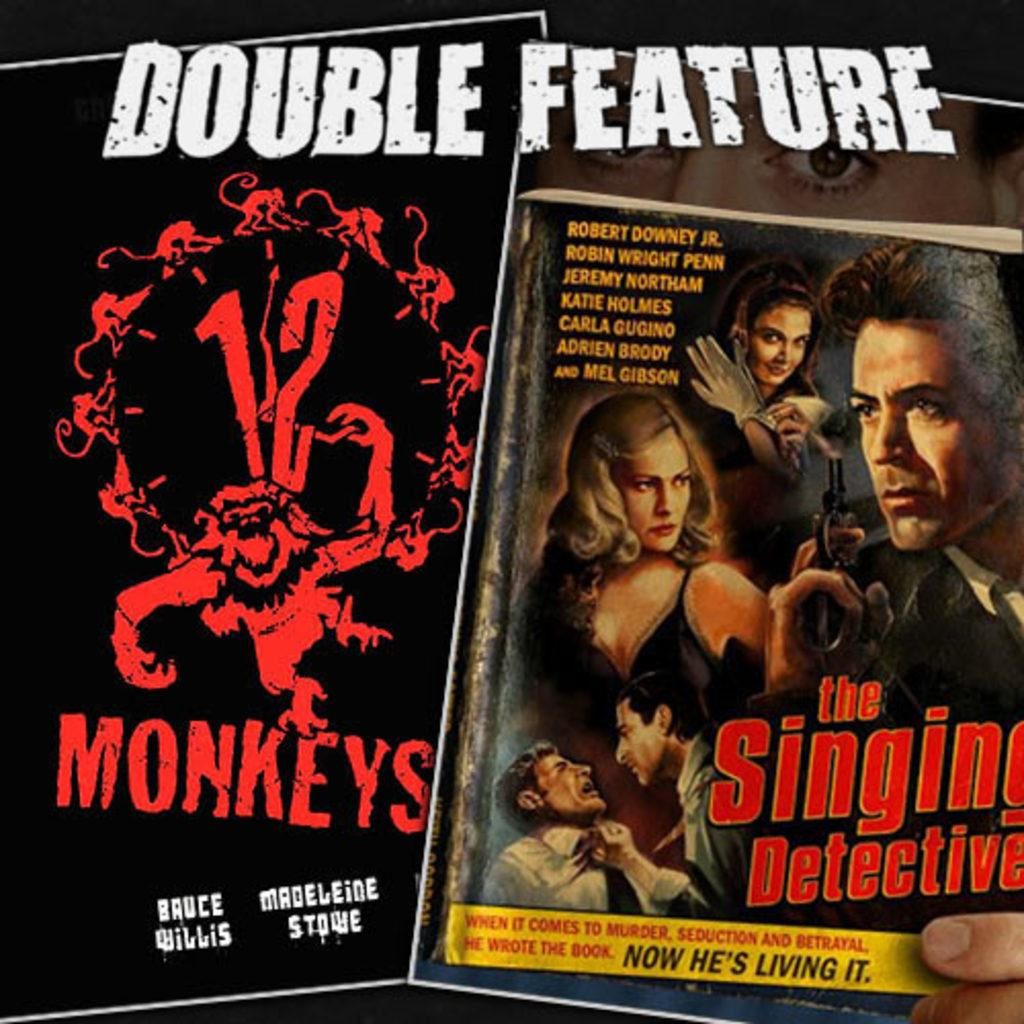Provide a one-sentence caption for the provided image. Two dvd covers are shown; one is 12 monkeys and the other is the singing detective. 